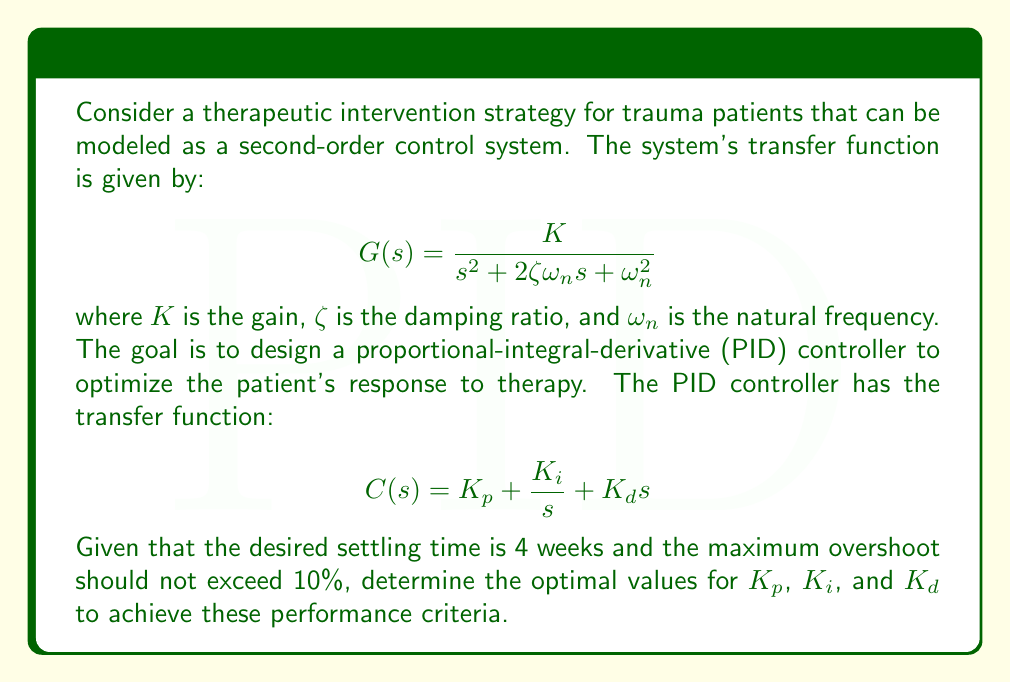Could you help me with this problem? To solve this problem, we'll follow these steps:

1) First, we need to determine the required damping ratio ($\zeta$) and natural frequency ($\omega_n$) based on the given performance criteria.

2) For a maximum overshoot of 10%, we can use the following equation:
   $$MP = e^{-\pi\zeta/\sqrt{1-\zeta^2}} \times 100\%$$
   Solving this, we get $\zeta \approx 0.591$

3) For the settling time ($T_s$) of 4 weeks, we use:
   $$T_s = \frac{4}{\zeta\omega_n}$$
   Substituting $\zeta = 0.591$ and $T_s = 4$, we get $\omega_n \approx 1.69$ rad/week

4) Now that we have $\zeta$ and $\omega_n$, we can design the PID controller. We'll use the Ziegler-Nichols tuning method for second-order systems:

   $$K_p = \frac{0.6K_u}{K}$$
   $$K_i = \frac{2K_p}{T_u}$$
   $$K_d = \frac{K_pT_u}{8}$$

   where $K_u$ is the ultimate gain and $T_u$ is the oscillation period.

5) For a second-order system, we can approximate:
   $$K_u \approx \frac{2\zeta\omega_n}{K}$$
   $$T_u \approx \frac{2\pi}{\omega_n}$$

6) Substituting these into the Ziegler-Nichols formulas:

   $$K_p = 1.2\zeta$$
   $$K_i = \frac{0.6\zeta\omega_n^2}{\pi}$$
   $$K_d = \frac{0.075}{\zeta\omega_n}$$

7) Finally, substituting our values for $\zeta$ and $\omega_n$:

   $$K_p = 1.2 \times 0.591 = 0.709$$
   $$K_i = \frac{0.6 \times 0.591 \times 1.69^2}{\pi} = 0.321$$
   $$K_d = \frac{0.075}{0.591 \times 1.69} = 0.075$$
Answer: The optimal PID controller parameters are:
$K_p = 0.709$
$K_i = 0.321$
$K_d = 0.075$ 